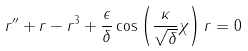Convert formula to latex. <formula><loc_0><loc_0><loc_500><loc_500>r ^ { \prime \prime } + r - r ^ { 3 } + \frac { \epsilon } { \delta } \cos \left ( \frac { \kappa } { \sqrt { \delta } } \chi \right ) r = 0</formula> 